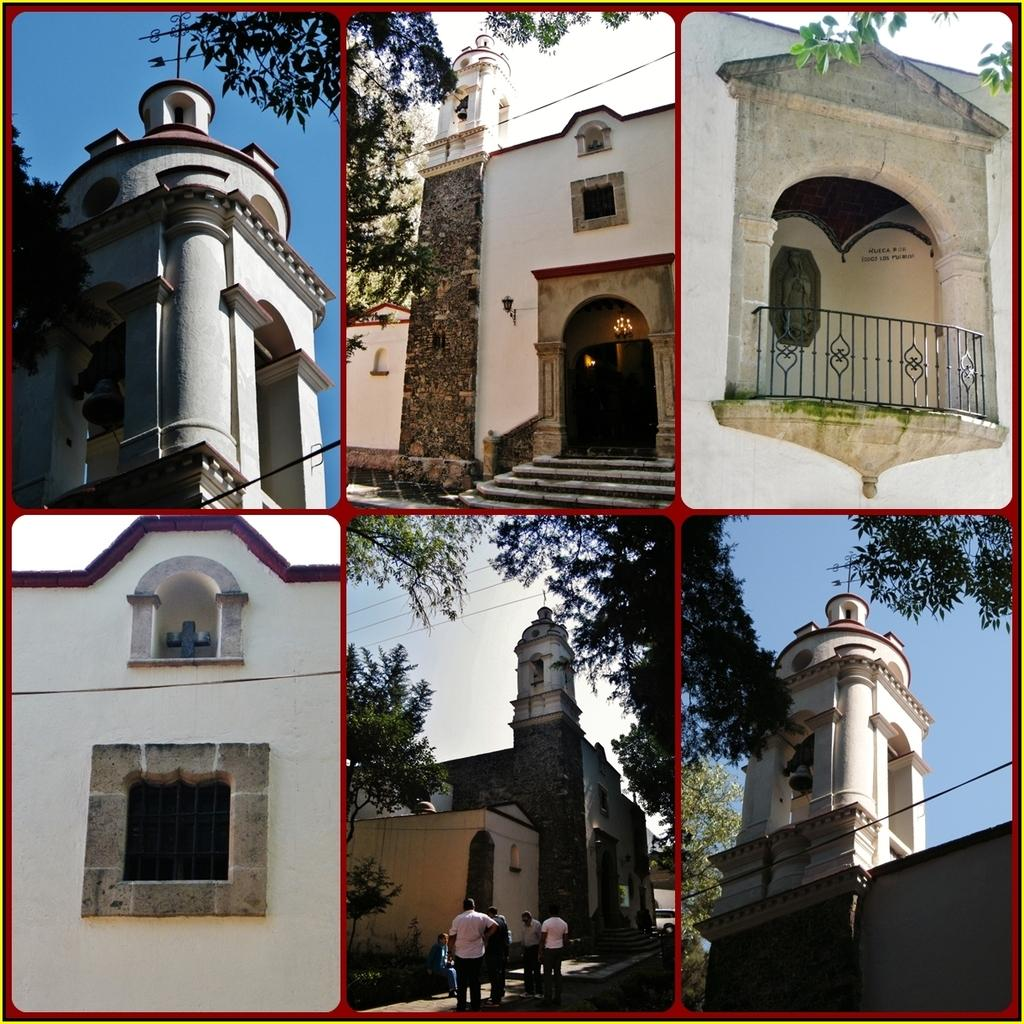What type of artwork is the image? The image is a collage. What structures can be seen in the collage? There are buildings in the image. What are the people in the image doing? People are walking on the road in the image. What type of vegetation is present in the collage? There are trees in the image. What other objects can be seen in the collage? Wires and steps are present in the image. What is visible in the background of the collage? The sky is visible in the background of the image. How many visitors are present in the image? There is no mention of visitors in the image; it features a collage with various subjects and objects. Are there any slaves depicted in the image? There is no mention of slaves in the image; it features a collage with various subjects and objects. 